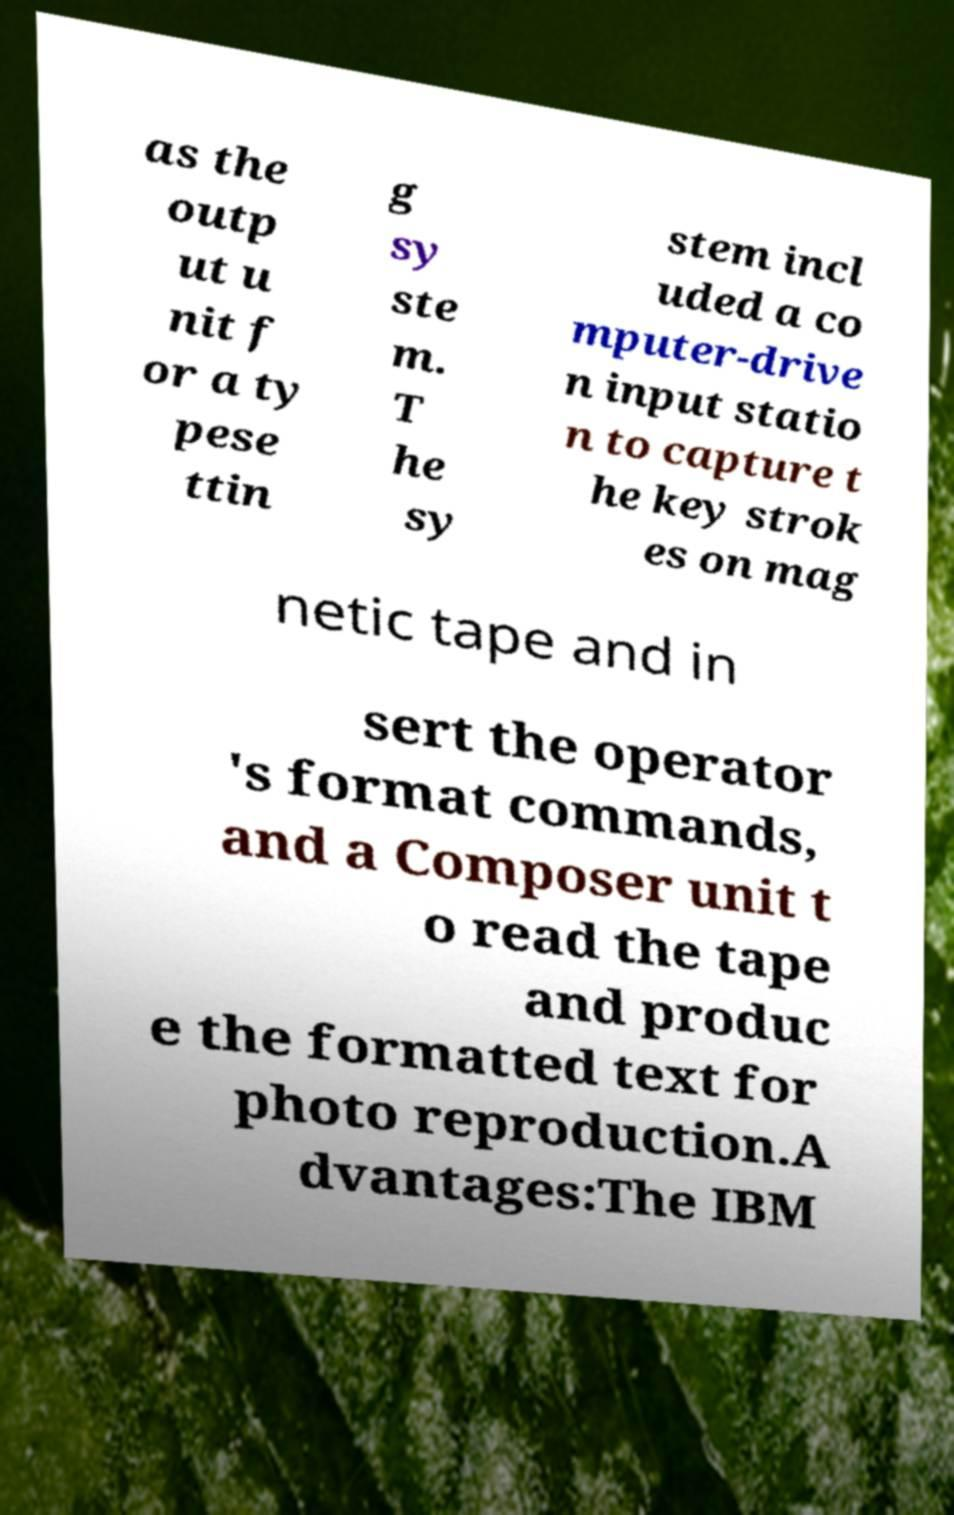There's text embedded in this image that I need extracted. Can you transcribe it verbatim? as the outp ut u nit f or a ty pese ttin g sy ste m. T he sy stem incl uded a co mputer-drive n input statio n to capture t he key strok es on mag netic tape and in sert the operator 's format commands, and a Composer unit t o read the tape and produc e the formatted text for photo reproduction.A dvantages:The IBM 